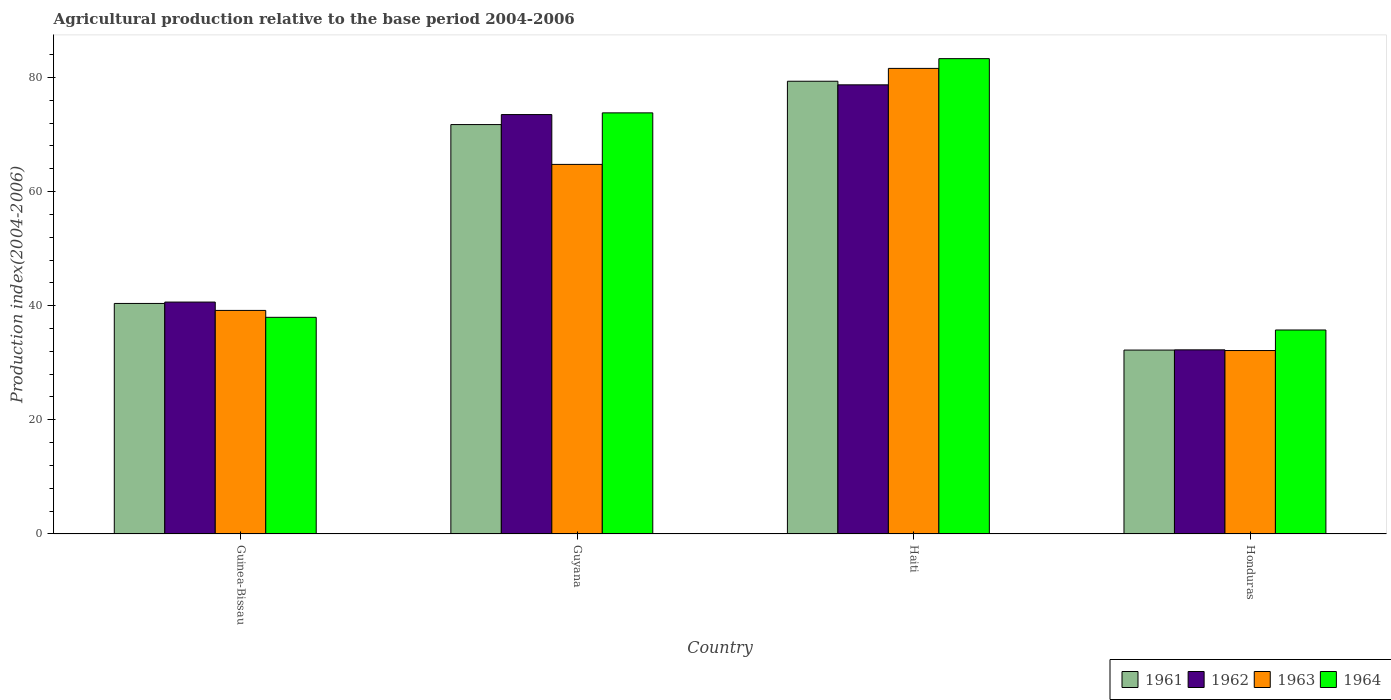How many groups of bars are there?
Offer a terse response. 4. Are the number of bars on each tick of the X-axis equal?
Give a very brief answer. Yes. How many bars are there on the 2nd tick from the left?
Provide a succinct answer. 4. How many bars are there on the 1st tick from the right?
Your response must be concise. 4. What is the label of the 1st group of bars from the left?
Make the answer very short. Guinea-Bissau. What is the agricultural production index in 1963 in Honduras?
Keep it short and to the point. 32.14. Across all countries, what is the maximum agricultural production index in 1964?
Offer a terse response. 83.28. Across all countries, what is the minimum agricultural production index in 1963?
Provide a short and direct response. 32.14. In which country was the agricultural production index in 1963 maximum?
Make the answer very short. Haiti. In which country was the agricultural production index in 1963 minimum?
Your answer should be very brief. Honduras. What is the total agricultural production index in 1961 in the graph?
Offer a terse response. 223.66. What is the difference between the agricultural production index in 1962 in Guyana and that in Honduras?
Your answer should be compact. 41.22. What is the difference between the agricultural production index in 1963 in Haiti and the agricultural production index in 1961 in Guyana?
Ensure brevity in your answer.  9.84. What is the average agricultural production index in 1963 per country?
Offer a terse response. 54.41. What is the difference between the agricultural production index of/in 1962 and agricultural production index of/in 1961 in Honduras?
Your response must be concise. 0.04. In how many countries, is the agricultural production index in 1961 greater than 72?
Make the answer very short. 1. What is the ratio of the agricultural production index in 1964 in Guinea-Bissau to that in Honduras?
Provide a succinct answer. 1.06. What is the difference between the highest and the second highest agricultural production index in 1962?
Offer a terse response. -32.85. What is the difference between the highest and the lowest agricultural production index in 1962?
Ensure brevity in your answer.  46.43. Is the sum of the agricultural production index in 1964 in Haiti and Honduras greater than the maximum agricultural production index in 1963 across all countries?
Keep it short and to the point. Yes. What does the 2nd bar from the left in Guinea-Bissau represents?
Your answer should be very brief. 1962. What is the difference between two consecutive major ticks on the Y-axis?
Offer a terse response. 20. Where does the legend appear in the graph?
Keep it short and to the point. Bottom right. How many legend labels are there?
Your answer should be very brief. 4. How are the legend labels stacked?
Your answer should be very brief. Horizontal. What is the title of the graph?
Offer a very short reply. Agricultural production relative to the base period 2004-2006. Does "2005" appear as one of the legend labels in the graph?
Offer a very short reply. No. What is the label or title of the Y-axis?
Make the answer very short. Production index(2004-2006). What is the Production index(2004-2006) of 1961 in Guinea-Bissau?
Provide a succinct answer. 40.39. What is the Production index(2004-2006) in 1962 in Guinea-Bissau?
Provide a short and direct response. 40.63. What is the Production index(2004-2006) in 1963 in Guinea-Bissau?
Your response must be concise. 39.17. What is the Production index(2004-2006) in 1964 in Guinea-Bissau?
Give a very brief answer. 37.96. What is the Production index(2004-2006) in 1961 in Guyana?
Give a very brief answer. 71.73. What is the Production index(2004-2006) in 1962 in Guyana?
Ensure brevity in your answer.  73.48. What is the Production index(2004-2006) in 1963 in Guyana?
Keep it short and to the point. 64.75. What is the Production index(2004-2006) of 1964 in Guyana?
Keep it short and to the point. 73.78. What is the Production index(2004-2006) of 1961 in Haiti?
Offer a very short reply. 79.32. What is the Production index(2004-2006) in 1962 in Haiti?
Your response must be concise. 78.69. What is the Production index(2004-2006) in 1963 in Haiti?
Your response must be concise. 81.57. What is the Production index(2004-2006) of 1964 in Haiti?
Offer a very short reply. 83.28. What is the Production index(2004-2006) of 1961 in Honduras?
Provide a short and direct response. 32.22. What is the Production index(2004-2006) in 1962 in Honduras?
Provide a succinct answer. 32.26. What is the Production index(2004-2006) in 1963 in Honduras?
Keep it short and to the point. 32.14. What is the Production index(2004-2006) in 1964 in Honduras?
Offer a very short reply. 35.74. Across all countries, what is the maximum Production index(2004-2006) in 1961?
Offer a terse response. 79.32. Across all countries, what is the maximum Production index(2004-2006) of 1962?
Your response must be concise. 78.69. Across all countries, what is the maximum Production index(2004-2006) in 1963?
Your answer should be very brief. 81.57. Across all countries, what is the maximum Production index(2004-2006) of 1964?
Provide a short and direct response. 83.28. Across all countries, what is the minimum Production index(2004-2006) in 1961?
Make the answer very short. 32.22. Across all countries, what is the minimum Production index(2004-2006) of 1962?
Give a very brief answer. 32.26. Across all countries, what is the minimum Production index(2004-2006) of 1963?
Offer a terse response. 32.14. Across all countries, what is the minimum Production index(2004-2006) in 1964?
Make the answer very short. 35.74. What is the total Production index(2004-2006) in 1961 in the graph?
Your response must be concise. 223.66. What is the total Production index(2004-2006) of 1962 in the graph?
Your answer should be very brief. 225.06. What is the total Production index(2004-2006) of 1963 in the graph?
Offer a very short reply. 217.63. What is the total Production index(2004-2006) in 1964 in the graph?
Provide a short and direct response. 230.76. What is the difference between the Production index(2004-2006) of 1961 in Guinea-Bissau and that in Guyana?
Ensure brevity in your answer.  -31.34. What is the difference between the Production index(2004-2006) in 1962 in Guinea-Bissau and that in Guyana?
Offer a very short reply. -32.85. What is the difference between the Production index(2004-2006) in 1963 in Guinea-Bissau and that in Guyana?
Your response must be concise. -25.58. What is the difference between the Production index(2004-2006) of 1964 in Guinea-Bissau and that in Guyana?
Provide a succinct answer. -35.82. What is the difference between the Production index(2004-2006) in 1961 in Guinea-Bissau and that in Haiti?
Offer a terse response. -38.93. What is the difference between the Production index(2004-2006) in 1962 in Guinea-Bissau and that in Haiti?
Keep it short and to the point. -38.06. What is the difference between the Production index(2004-2006) in 1963 in Guinea-Bissau and that in Haiti?
Offer a terse response. -42.4. What is the difference between the Production index(2004-2006) of 1964 in Guinea-Bissau and that in Haiti?
Your response must be concise. -45.32. What is the difference between the Production index(2004-2006) in 1961 in Guinea-Bissau and that in Honduras?
Provide a short and direct response. 8.17. What is the difference between the Production index(2004-2006) in 1962 in Guinea-Bissau and that in Honduras?
Keep it short and to the point. 8.37. What is the difference between the Production index(2004-2006) of 1963 in Guinea-Bissau and that in Honduras?
Offer a very short reply. 7.03. What is the difference between the Production index(2004-2006) of 1964 in Guinea-Bissau and that in Honduras?
Give a very brief answer. 2.22. What is the difference between the Production index(2004-2006) of 1961 in Guyana and that in Haiti?
Offer a terse response. -7.59. What is the difference between the Production index(2004-2006) in 1962 in Guyana and that in Haiti?
Your answer should be compact. -5.21. What is the difference between the Production index(2004-2006) of 1963 in Guyana and that in Haiti?
Provide a succinct answer. -16.82. What is the difference between the Production index(2004-2006) of 1961 in Guyana and that in Honduras?
Ensure brevity in your answer.  39.51. What is the difference between the Production index(2004-2006) in 1962 in Guyana and that in Honduras?
Your response must be concise. 41.22. What is the difference between the Production index(2004-2006) in 1963 in Guyana and that in Honduras?
Keep it short and to the point. 32.61. What is the difference between the Production index(2004-2006) of 1964 in Guyana and that in Honduras?
Keep it short and to the point. 38.04. What is the difference between the Production index(2004-2006) in 1961 in Haiti and that in Honduras?
Offer a very short reply. 47.1. What is the difference between the Production index(2004-2006) of 1962 in Haiti and that in Honduras?
Give a very brief answer. 46.43. What is the difference between the Production index(2004-2006) of 1963 in Haiti and that in Honduras?
Make the answer very short. 49.43. What is the difference between the Production index(2004-2006) in 1964 in Haiti and that in Honduras?
Ensure brevity in your answer.  47.54. What is the difference between the Production index(2004-2006) of 1961 in Guinea-Bissau and the Production index(2004-2006) of 1962 in Guyana?
Provide a short and direct response. -33.09. What is the difference between the Production index(2004-2006) of 1961 in Guinea-Bissau and the Production index(2004-2006) of 1963 in Guyana?
Keep it short and to the point. -24.36. What is the difference between the Production index(2004-2006) of 1961 in Guinea-Bissau and the Production index(2004-2006) of 1964 in Guyana?
Your answer should be compact. -33.39. What is the difference between the Production index(2004-2006) in 1962 in Guinea-Bissau and the Production index(2004-2006) in 1963 in Guyana?
Ensure brevity in your answer.  -24.12. What is the difference between the Production index(2004-2006) in 1962 in Guinea-Bissau and the Production index(2004-2006) in 1964 in Guyana?
Your answer should be compact. -33.15. What is the difference between the Production index(2004-2006) of 1963 in Guinea-Bissau and the Production index(2004-2006) of 1964 in Guyana?
Give a very brief answer. -34.61. What is the difference between the Production index(2004-2006) of 1961 in Guinea-Bissau and the Production index(2004-2006) of 1962 in Haiti?
Offer a terse response. -38.3. What is the difference between the Production index(2004-2006) of 1961 in Guinea-Bissau and the Production index(2004-2006) of 1963 in Haiti?
Give a very brief answer. -41.18. What is the difference between the Production index(2004-2006) in 1961 in Guinea-Bissau and the Production index(2004-2006) in 1964 in Haiti?
Ensure brevity in your answer.  -42.89. What is the difference between the Production index(2004-2006) of 1962 in Guinea-Bissau and the Production index(2004-2006) of 1963 in Haiti?
Your answer should be very brief. -40.94. What is the difference between the Production index(2004-2006) of 1962 in Guinea-Bissau and the Production index(2004-2006) of 1964 in Haiti?
Your response must be concise. -42.65. What is the difference between the Production index(2004-2006) in 1963 in Guinea-Bissau and the Production index(2004-2006) in 1964 in Haiti?
Offer a terse response. -44.11. What is the difference between the Production index(2004-2006) of 1961 in Guinea-Bissau and the Production index(2004-2006) of 1962 in Honduras?
Your response must be concise. 8.13. What is the difference between the Production index(2004-2006) in 1961 in Guinea-Bissau and the Production index(2004-2006) in 1963 in Honduras?
Your answer should be compact. 8.25. What is the difference between the Production index(2004-2006) in 1961 in Guinea-Bissau and the Production index(2004-2006) in 1964 in Honduras?
Your answer should be very brief. 4.65. What is the difference between the Production index(2004-2006) in 1962 in Guinea-Bissau and the Production index(2004-2006) in 1963 in Honduras?
Offer a terse response. 8.49. What is the difference between the Production index(2004-2006) of 1962 in Guinea-Bissau and the Production index(2004-2006) of 1964 in Honduras?
Give a very brief answer. 4.89. What is the difference between the Production index(2004-2006) of 1963 in Guinea-Bissau and the Production index(2004-2006) of 1964 in Honduras?
Provide a succinct answer. 3.43. What is the difference between the Production index(2004-2006) in 1961 in Guyana and the Production index(2004-2006) in 1962 in Haiti?
Your response must be concise. -6.96. What is the difference between the Production index(2004-2006) in 1961 in Guyana and the Production index(2004-2006) in 1963 in Haiti?
Offer a terse response. -9.84. What is the difference between the Production index(2004-2006) of 1961 in Guyana and the Production index(2004-2006) of 1964 in Haiti?
Make the answer very short. -11.55. What is the difference between the Production index(2004-2006) in 1962 in Guyana and the Production index(2004-2006) in 1963 in Haiti?
Provide a short and direct response. -8.09. What is the difference between the Production index(2004-2006) in 1963 in Guyana and the Production index(2004-2006) in 1964 in Haiti?
Your response must be concise. -18.53. What is the difference between the Production index(2004-2006) of 1961 in Guyana and the Production index(2004-2006) of 1962 in Honduras?
Offer a very short reply. 39.47. What is the difference between the Production index(2004-2006) in 1961 in Guyana and the Production index(2004-2006) in 1963 in Honduras?
Offer a terse response. 39.59. What is the difference between the Production index(2004-2006) in 1961 in Guyana and the Production index(2004-2006) in 1964 in Honduras?
Give a very brief answer. 35.99. What is the difference between the Production index(2004-2006) of 1962 in Guyana and the Production index(2004-2006) of 1963 in Honduras?
Offer a very short reply. 41.34. What is the difference between the Production index(2004-2006) of 1962 in Guyana and the Production index(2004-2006) of 1964 in Honduras?
Your response must be concise. 37.74. What is the difference between the Production index(2004-2006) in 1963 in Guyana and the Production index(2004-2006) in 1964 in Honduras?
Offer a very short reply. 29.01. What is the difference between the Production index(2004-2006) of 1961 in Haiti and the Production index(2004-2006) of 1962 in Honduras?
Your answer should be very brief. 47.06. What is the difference between the Production index(2004-2006) in 1961 in Haiti and the Production index(2004-2006) in 1963 in Honduras?
Offer a very short reply. 47.18. What is the difference between the Production index(2004-2006) in 1961 in Haiti and the Production index(2004-2006) in 1964 in Honduras?
Offer a very short reply. 43.58. What is the difference between the Production index(2004-2006) of 1962 in Haiti and the Production index(2004-2006) of 1963 in Honduras?
Your answer should be compact. 46.55. What is the difference between the Production index(2004-2006) in 1962 in Haiti and the Production index(2004-2006) in 1964 in Honduras?
Make the answer very short. 42.95. What is the difference between the Production index(2004-2006) of 1963 in Haiti and the Production index(2004-2006) of 1964 in Honduras?
Offer a terse response. 45.83. What is the average Production index(2004-2006) in 1961 per country?
Provide a succinct answer. 55.91. What is the average Production index(2004-2006) in 1962 per country?
Offer a very short reply. 56.27. What is the average Production index(2004-2006) in 1963 per country?
Keep it short and to the point. 54.41. What is the average Production index(2004-2006) of 1964 per country?
Your answer should be compact. 57.69. What is the difference between the Production index(2004-2006) in 1961 and Production index(2004-2006) in 1962 in Guinea-Bissau?
Give a very brief answer. -0.24. What is the difference between the Production index(2004-2006) in 1961 and Production index(2004-2006) in 1963 in Guinea-Bissau?
Offer a very short reply. 1.22. What is the difference between the Production index(2004-2006) of 1961 and Production index(2004-2006) of 1964 in Guinea-Bissau?
Your answer should be compact. 2.43. What is the difference between the Production index(2004-2006) of 1962 and Production index(2004-2006) of 1963 in Guinea-Bissau?
Provide a succinct answer. 1.46. What is the difference between the Production index(2004-2006) of 1962 and Production index(2004-2006) of 1964 in Guinea-Bissau?
Provide a succinct answer. 2.67. What is the difference between the Production index(2004-2006) in 1963 and Production index(2004-2006) in 1964 in Guinea-Bissau?
Provide a short and direct response. 1.21. What is the difference between the Production index(2004-2006) in 1961 and Production index(2004-2006) in 1962 in Guyana?
Keep it short and to the point. -1.75. What is the difference between the Production index(2004-2006) of 1961 and Production index(2004-2006) of 1963 in Guyana?
Make the answer very short. 6.98. What is the difference between the Production index(2004-2006) in 1961 and Production index(2004-2006) in 1964 in Guyana?
Make the answer very short. -2.05. What is the difference between the Production index(2004-2006) of 1962 and Production index(2004-2006) of 1963 in Guyana?
Your answer should be compact. 8.73. What is the difference between the Production index(2004-2006) in 1963 and Production index(2004-2006) in 1964 in Guyana?
Your answer should be very brief. -9.03. What is the difference between the Production index(2004-2006) in 1961 and Production index(2004-2006) in 1962 in Haiti?
Your response must be concise. 0.63. What is the difference between the Production index(2004-2006) of 1961 and Production index(2004-2006) of 1963 in Haiti?
Give a very brief answer. -2.25. What is the difference between the Production index(2004-2006) of 1961 and Production index(2004-2006) of 1964 in Haiti?
Offer a terse response. -3.96. What is the difference between the Production index(2004-2006) in 1962 and Production index(2004-2006) in 1963 in Haiti?
Your response must be concise. -2.88. What is the difference between the Production index(2004-2006) in 1962 and Production index(2004-2006) in 1964 in Haiti?
Ensure brevity in your answer.  -4.59. What is the difference between the Production index(2004-2006) in 1963 and Production index(2004-2006) in 1964 in Haiti?
Provide a succinct answer. -1.71. What is the difference between the Production index(2004-2006) in 1961 and Production index(2004-2006) in 1962 in Honduras?
Give a very brief answer. -0.04. What is the difference between the Production index(2004-2006) of 1961 and Production index(2004-2006) of 1964 in Honduras?
Offer a terse response. -3.52. What is the difference between the Production index(2004-2006) of 1962 and Production index(2004-2006) of 1963 in Honduras?
Keep it short and to the point. 0.12. What is the difference between the Production index(2004-2006) of 1962 and Production index(2004-2006) of 1964 in Honduras?
Ensure brevity in your answer.  -3.48. What is the ratio of the Production index(2004-2006) in 1961 in Guinea-Bissau to that in Guyana?
Provide a succinct answer. 0.56. What is the ratio of the Production index(2004-2006) in 1962 in Guinea-Bissau to that in Guyana?
Offer a terse response. 0.55. What is the ratio of the Production index(2004-2006) of 1963 in Guinea-Bissau to that in Guyana?
Ensure brevity in your answer.  0.6. What is the ratio of the Production index(2004-2006) of 1964 in Guinea-Bissau to that in Guyana?
Give a very brief answer. 0.51. What is the ratio of the Production index(2004-2006) in 1961 in Guinea-Bissau to that in Haiti?
Give a very brief answer. 0.51. What is the ratio of the Production index(2004-2006) of 1962 in Guinea-Bissau to that in Haiti?
Give a very brief answer. 0.52. What is the ratio of the Production index(2004-2006) of 1963 in Guinea-Bissau to that in Haiti?
Provide a short and direct response. 0.48. What is the ratio of the Production index(2004-2006) of 1964 in Guinea-Bissau to that in Haiti?
Your answer should be very brief. 0.46. What is the ratio of the Production index(2004-2006) of 1961 in Guinea-Bissau to that in Honduras?
Your answer should be very brief. 1.25. What is the ratio of the Production index(2004-2006) of 1962 in Guinea-Bissau to that in Honduras?
Offer a terse response. 1.26. What is the ratio of the Production index(2004-2006) of 1963 in Guinea-Bissau to that in Honduras?
Keep it short and to the point. 1.22. What is the ratio of the Production index(2004-2006) of 1964 in Guinea-Bissau to that in Honduras?
Give a very brief answer. 1.06. What is the ratio of the Production index(2004-2006) of 1961 in Guyana to that in Haiti?
Your response must be concise. 0.9. What is the ratio of the Production index(2004-2006) in 1962 in Guyana to that in Haiti?
Your answer should be very brief. 0.93. What is the ratio of the Production index(2004-2006) in 1963 in Guyana to that in Haiti?
Offer a terse response. 0.79. What is the ratio of the Production index(2004-2006) of 1964 in Guyana to that in Haiti?
Offer a terse response. 0.89. What is the ratio of the Production index(2004-2006) of 1961 in Guyana to that in Honduras?
Provide a short and direct response. 2.23. What is the ratio of the Production index(2004-2006) in 1962 in Guyana to that in Honduras?
Ensure brevity in your answer.  2.28. What is the ratio of the Production index(2004-2006) of 1963 in Guyana to that in Honduras?
Ensure brevity in your answer.  2.01. What is the ratio of the Production index(2004-2006) in 1964 in Guyana to that in Honduras?
Ensure brevity in your answer.  2.06. What is the ratio of the Production index(2004-2006) in 1961 in Haiti to that in Honduras?
Your response must be concise. 2.46. What is the ratio of the Production index(2004-2006) of 1962 in Haiti to that in Honduras?
Your answer should be very brief. 2.44. What is the ratio of the Production index(2004-2006) in 1963 in Haiti to that in Honduras?
Your response must be concise. 2.54. What is the ratio of the Production index(2004-2006) of 1964 in Haiti to that in Honduras?
Make the answer very short. 2.33. What is the difference between the highest and the second highest Production index(2004-2006) in 1961?
Offer a terse response. 7.59. What is the difference between the highest and the second highest Production index(2004-2006) of 1962?
Give a very brief answer. 5.21. What is the difference between the highest and the second highest Production index(2004-2006) in 1963?
Offer a very short reply. 16.82. What is the difference between the highest and the second highest Production index(2004-2006) of 1964?
Your answer should be very brief. 9.5. What is the difference between the highest and the lowest Production index(2004-2006) in 1961?
Provide a short and direct response. 47.1. What is the difference between the highest and the lowest Production index(2004-2006) of 1962?
Keep it short and to the point. 46.43. What is the difference between the highest and the lowest Production index(2004-2006) of 1963?
Offer a terse response. 49.43. What is the difference between the highest and the lowest Production index(2004-2006) of 1964?
Your answer should be compact. 47.54. 